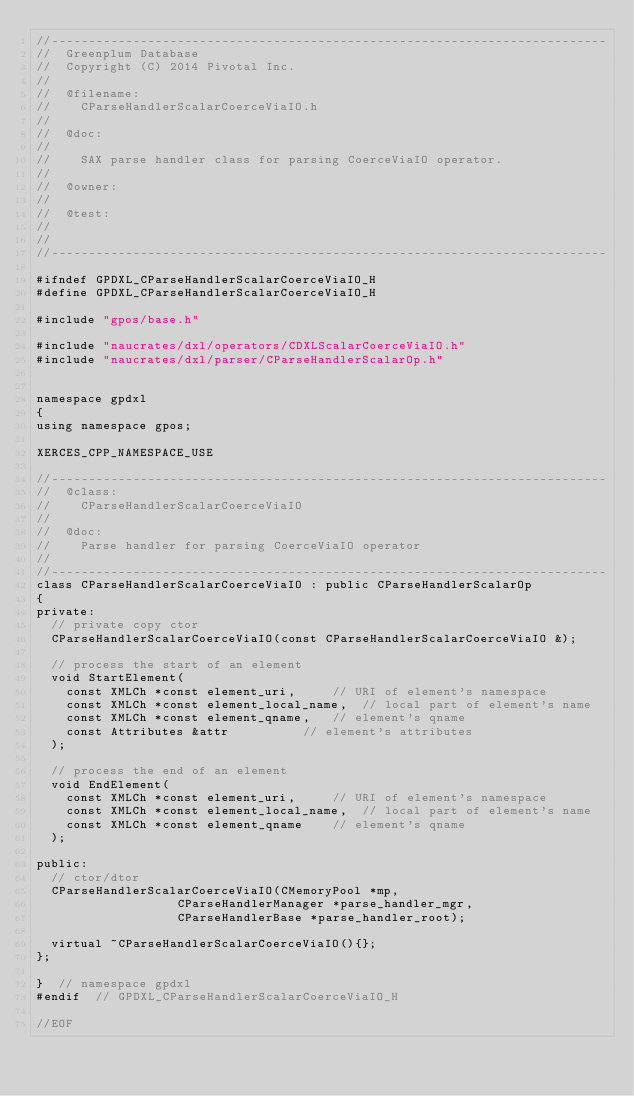<code> <loc_0><loc_0><loc_500><loc_500><_C_>//---------------------------------------------------------------------------
//	Greenplum Database
//	Copyright (C) 2014 Pivotal Inc.
//
//	@filename:
//		CParseHandlerScalarCoerceViaIO.h
//
//	@doc:
//
//		SAX parse handler class for parsing CoerceViaIO operator.
//
//	@owner:
//
//	@test:
//
//
//---------------------------------------------------------------------------

#ifndef GPDXL_CParseHandlerScalarCoerceViaIO_H
#define GPDXL_CParseHandlerScalarCoerceViaIO_H

#include "gpos/base.h"

#include "naucrates/dxl/operators/CDXLScalarCoerceViaIO.h"
#include "naucrates/dxl/parser/CParseHandlerScalarOp.h"


namespace gpdxl
{
using namespace gpos;

XERCES_CPP_NAMESPACE_USE

//---------------------------------------------------------------------------
//	@class:
//		CParseHandlerScalarCoerceViaIO
//
//	@doc:
//		Parse handler for parsing CoerceViaIO operator
//
//---------------------------------------------------------------------------
class CParseHandlerScalarCoerceViaIO : public CParseHandlerScalarOp
{
private:
	// private copy ctor
	CParseHandlerScalarCoerceViaIO(const CParseHandlerScalarCoerceViaIO &);

	// process the start of an element
	void StartElement(
		const XMLCh *const element_uri,			// URI of element's namespace
		const XMLCh *const element_local_name,	// local part of element's name
		const XMLCh *const element_qname,		// element's qname
		const Attributes &attr					// element's attributes
	);

	// process the end of an element
	void EndElement(
		const XMLCh *const element_uri,			// URI of element's namespace
		const XMLCh *const element_local_name,	// local part of element's name
		const XMLCh *const element_qname		// element's qname
	);

public:
	// ctor/dtor
	CParseHandlerScalarCoerceViaIO(CMemoryPool *mp,
								   CParseHandlerManager *parse_handler_mgr,
								   CParseHandlerBase *parse_handler_root);

	virtual ~CParseHandlerScalarCoerceViaIO(){};
};

}  // namespace gpdxl
#endif	// GPDXL_CParseHandlerScalarCoerceViaIO_H

//EOF
</code> 